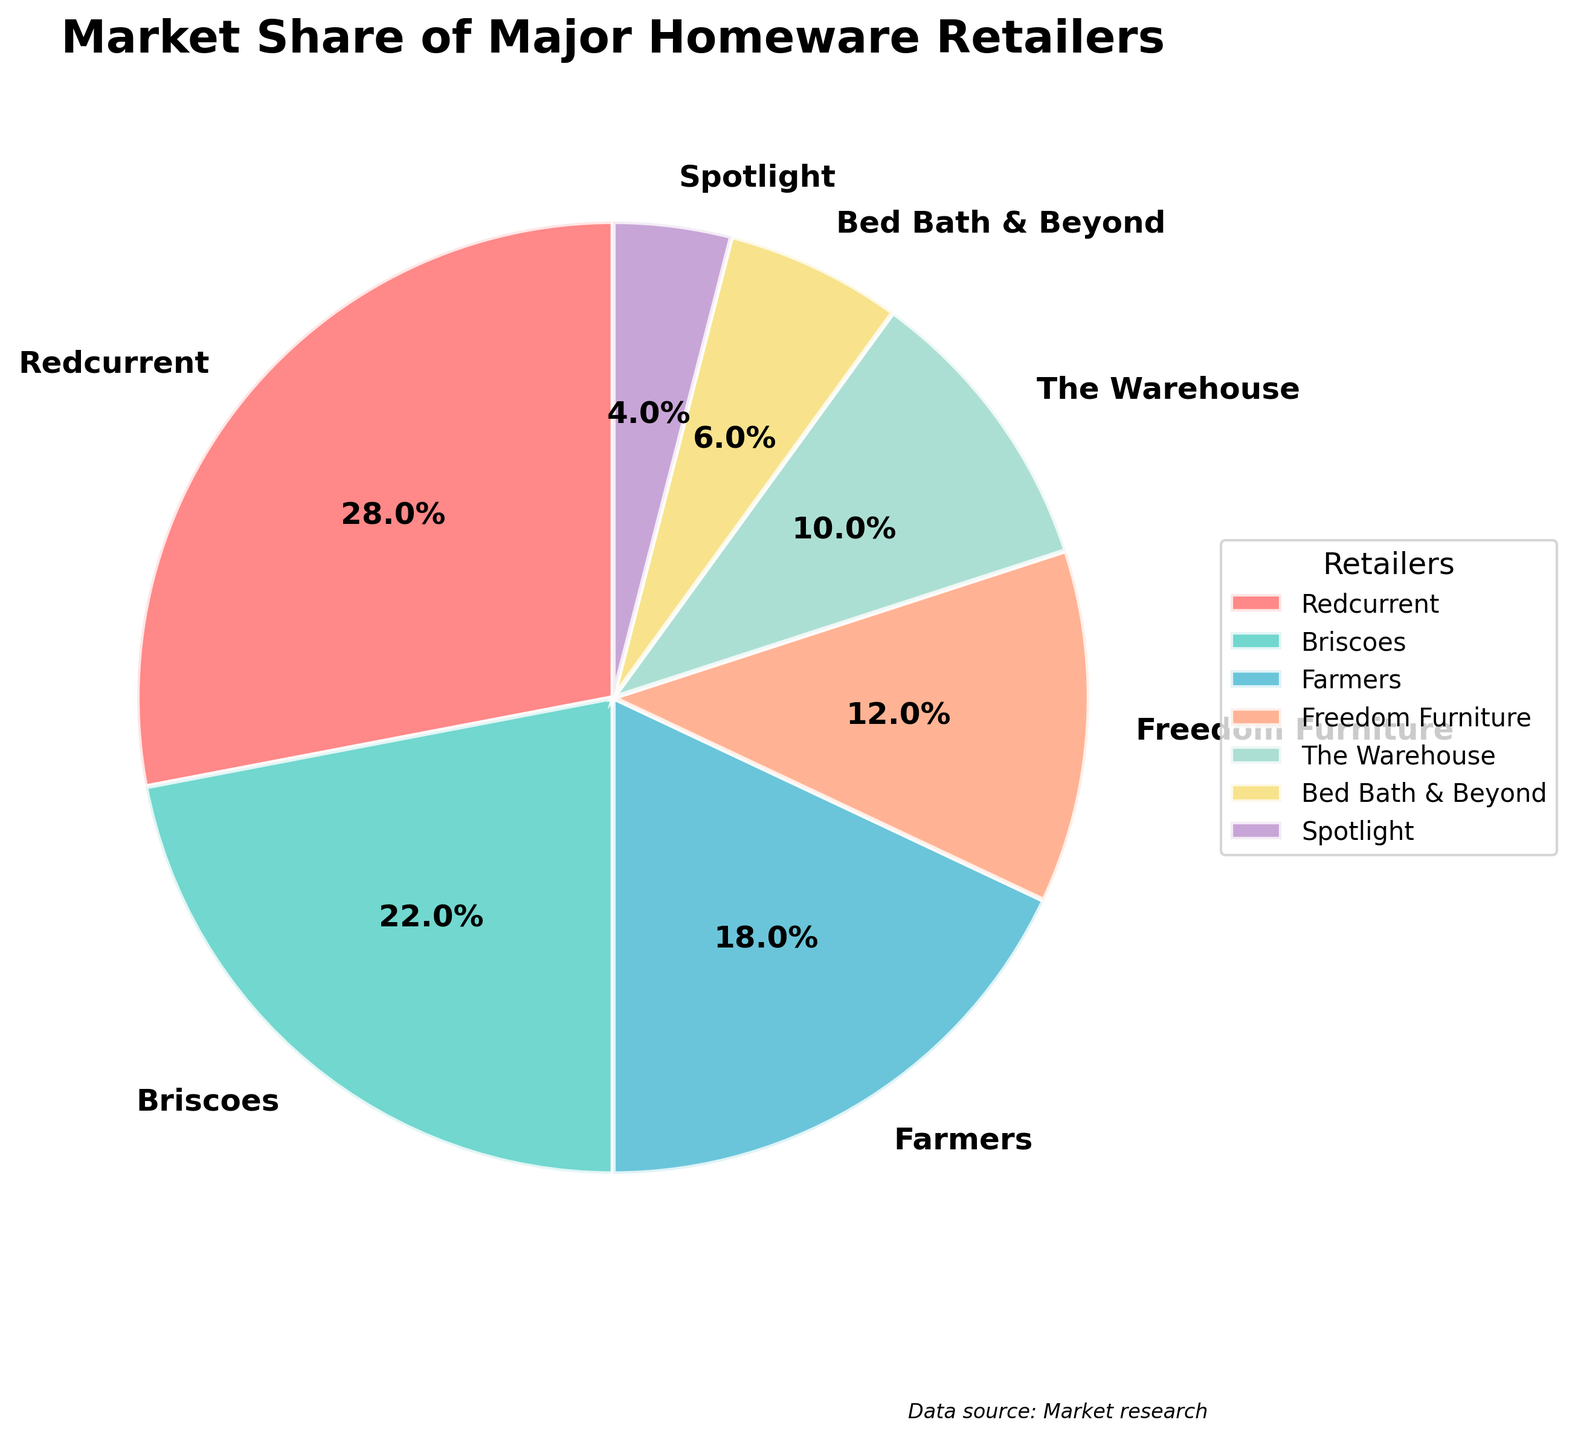Which retailer has the largest market share? Look at the pie chart segment that takes up the largest portion and note its label.
Answer: Redcurrent Which retailer has a market share greater than Farmers but less than Briscoes? Identify the market share values for Farmers and Briscoes (18% and 22%, respectively). Then find a segment with a market share between these two values.
Answer: None What is the combined market share of The Warehouse and Bed Bath & Beyond? Add the market shares of The Warehouse and Bed Bath & Beyond (10% + 6%).
Answer: 16% How much more market share does Redcurrent have compared to Spotlight? Subtract the market share of Spotlight from Redcurrent (28% - 4%).
Answer: 24% What color is the segment representing Briscoes? Identify the color used in the segment labeled Briscoes.
Answer: Greenish blue Which two retailers have a combined market share close to 30%? Look for pairs of retailers whose combined market share is close to 30%. The closest pair is Farmers and Freedom Furniture (18% + 12%).
Answer: Farmers and Freedom Furniture Which company shares a similar market share color with Redcurrent's? Identify the color used for Redcurrent (red). No other segment should have the same color.
Answer: None How much more market share do the top three retailers have compared to the bottom three? Add the market shares of the top three retailers (Redcurrent, Briscoes, Farmers: 28% + 22% + 18%). Then add the market shares of the bottom three (The Warehouse, Bed Bath & Beyond, Spotlight: 10% + 6% + 4%). Subtract the total market share of the bottom three from the top three (68% - 20%).
Answer: 48% Which retailer's market share is closest to one-third of Redcurrent's market share? Calculate one-third of Redcurrent's market share (28% / 3 ≈ 9.33%). Identify the retailer with a market share closest to this value (The Warehouse with 10%).
Answer: The Warehouse If Freedom Furniture's market share increased by 4%, which retailer would it surpass in market share? Add 4% to Freedom Furniture's market share (12% + 4% = 16%). Find which retailer's current market share is just below 16% (Farmers with 18%).
Answer: None 